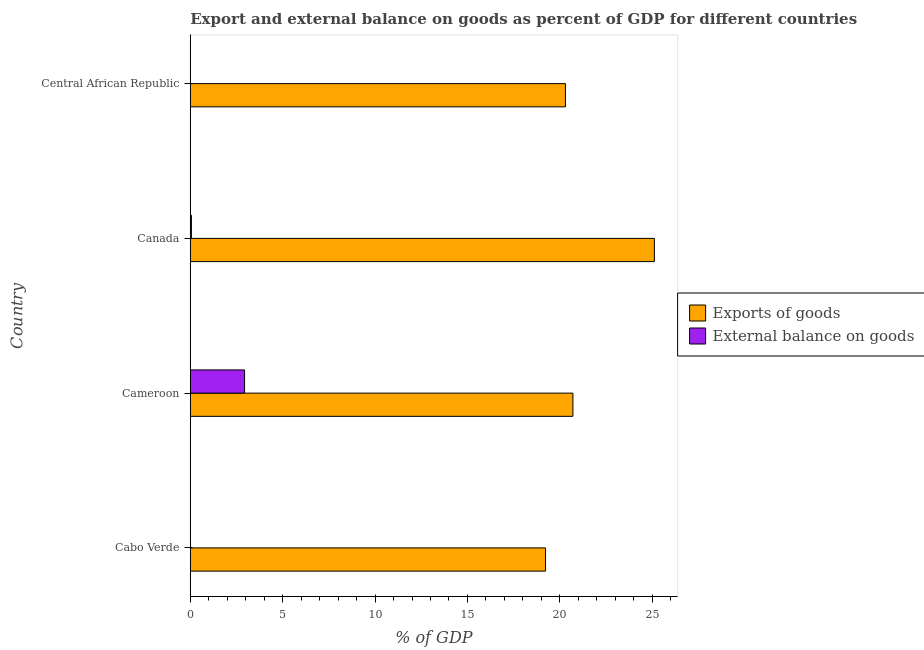How many bars are there on the 1st tick from the top?
Keep it short and to the point. 1. How many bars are there on the 4th tick from the bottom?
Provide a succinct answer. 1. What is the label of the 3rd group of bars from the top?
Your response must be concise. Cameroon. What is the export of goods as percentage of gdp in Cabo Verde?
Ensure brevity in your answer.  19.23. Across all countries, what is the maximum external balance on goods as percentage of gdp?
Offer a very short reply. 2.94. What is the total export of goods as percentage of gdp in the graph?
Give a very brief answer. 85.35. What is the difference between the external balance on goods as percentage of gdp in Cameroon and that in Canada?
Provide a short and direct response. 2.88. What is the difference between the export of goods as percentage of gdp in Cameroon and the external balance on goods as percentage of gdp in Cabo Verde?
Your answer should be compact. 20.71. What is the average external balance on goods as percentage of gdp per country?
Your answer should be very brief. 0.75. What is the difference between the export of goods as percentage of gdp and external balance on goods as percentage of gdp in Canada?
Your answer should be compact. 25.06. What is the ratio of the export of goods as percentage of gdp in Cabo Verde to that in Central African Republic?
Make the answer very short. 0.95. Is the difference between the external balance on goods as percentage of gdp in Cameroon and Canada greater than the difference between the export of goods as percentage of gdp in Cameroon and Canada?
Ensure brevity in your answer.  Yes. What is the difference between the highest and the second highest export of goods as percentage of gdp?
Keep it short and to the point. 4.41. What is the difference between the highest and the lowest export of goods as percentage of gdp?
Offer a very short reply. 5.89. How many bars are there?
Offer a terse response. 6. Are all the bars in the graph horizontal?
Offer a very short reply. Yes. What is the difference between two consecutive major ticks on the X-axis?
Keep it short and to the point. 5. Are the values on the major ticks of X-axis written in scientific E-notation?
Provide a short and direct response. No. Where does the legend appear in the graph?
Your answer should be compact. Center right. What is the title of the graph?
Make the answer very short. Export and external balance on goods as percent of GDP for different countries. What is the label or title of the X-axis?
Your answer should be compact. % of GDP. What is the % of GDP in Exports of goods in Cabo Verde?
Your response must be concise. 19.23. What is the % of GDP of External balance on goods in Cabo Verde?
Offer a very short reply. 0. What is the % of GDP in Exports of goods in Cameroon?
Your answer should be compact. 20.71. What is the % of GDP in External balance on goods in Cameroon?
Keep it short and to the point. 2.94. What is the % of GDP in Exports of goods in Canada?
Offer a terse response. 25.12. What is the % of GDP in External balance on goods in Canada?
Provide a succinct answer. 0.06. What is the % of GDP in Exports of goods in Central African Republic?
Give a very brief answer. 20.3. Across all countries, what is the maximum % of GDP in Exports of goods?
Provide a short and direct response. 25.12. Across all countries, what is the maximum % of GDP of External balance on goods?
Give a very brief answer. 2.94. Across all countries, what is the minimum % of GDP in Exports of goods?
Your answer should be very brief. 19.23. Across all countries, what is the minimum % of GDP of External balance on goods?
Your answer should be compact. 0. What is the total % of GDP in Exports of goods in the graph?
Offer a terse response. 85.35. What is the total % of GDP of External balance on goods in the graph?
Give a very brief answer. 3. What is the difference between the % of GDP in Exports of goods in Cabo Verde and that in Cameroon?
Offer a very short reply. -1.48. What is the difference between the % of GDP of Exports of goods in Cabo Verde and that in Canada?
Offer a very short reply. -5.89. What is the difference between the % of GDP in Exports of goods in Cabo Verde and that in Central African Republic?
Your answer should be compact. -1.08. What is the difference between the % of GDP in Exports of goods in Cameroon and that in Canada?
Provide a short and direct response. -4.41. What is the difference between the % of GDP of External balance on goods in Cameroon and that in Canada?
Your answer should be very brief. 2.88. What is the difference between the % of GDP in Exports of goods in Cameroon and that in Central African Republic?
Make the answer very short. 0.4. What is the difference between the % of GDP of Exports of goods in Canada and that in Central African Republic?
Keep it short and to the point. 4.81. What is the difference between the % of GDP in Exports of goods in Cabo Verde and the % of GDP in External balance on goods in Cameroon?
Make the answer very short. 16.29. What is the difference between the % of GDP in Exports of goods in Cabo Verde and the % of GDP in External balance on goods in Canada?
Offer a terse response. 19.17. What is the difference between the % of GDP of Exports of goods in Cameroon and the % of GDP of External balance on goods in Canada?
Keep it short and to the point. 20.65. What is the average % of GDP of Exports of goods per country?
Provide a succinct answer. 21.34. What is the average % of GDP in External balance on goods per country?
Provide a short and direct response. 0.75. What is the difference between the % of GDP of Exports of goods and % of GDP of External balance on goods in Cameroon?
Your answer should be compact. 17.77. What is the difference between the % of GDP in Exports of goods and % of GDP in External balance on goods in Canada?
Make the answer very short. 25.06. What is the ratio of the % of GDP in Exports of goods in Cabo Verde to that in Cameroon?
Make the answer very short. 0.93. What is the ratio of the % of GDP of Exports of goods in Cabo Verde to that in Canada?
Your response must be concise. 0.77. What is the ratio of the % of GDP in Exports of goods in Cabo Verde to that in Central African Republic?
Your answer should be compact. 0.95. What is the ratio of the % of GDP in Exports of goods in Cameroon to that in Canada?
Keep it short and to the point. 0.82. What is the ratio of the % of GDP of External balance on goods in Cameroon to that in Canada?
Offer a very short reply. 48.89. What is the ratio of the % of GDP in Exports of goods in Cameroon to that in Central African Republic?
Keep it short and to the point. 1.02. What is the ratio of the % of GDP in Exports of goods in Canada to that in Central African Republic?
Make the answer very short. 1.24. What is the difference between the highest and the second highest % of GDP of Exports of goods?
Ensure brevity in your answer.  4.41. What is the difference between the highest and the lowest % of GDP in Exports of goods?
Offer a very short reply. 5.89. What is the difference between the highest and the lowest % of GDP of External balance on goods?
Ensure brevity in your answer.  2.94. 